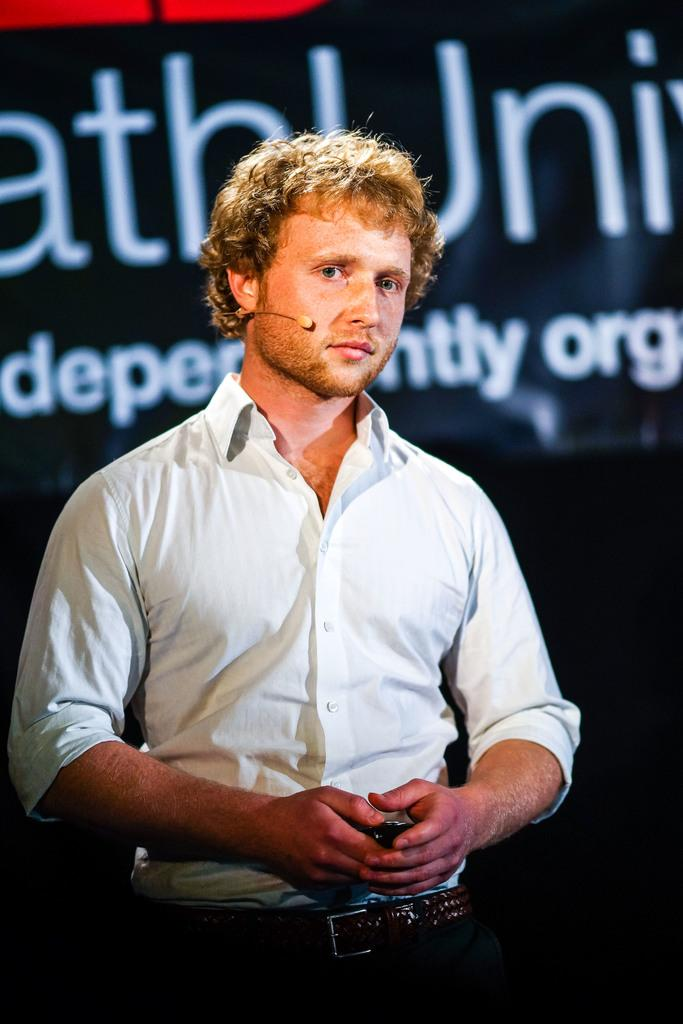Who is present in the image? There is a man in the image. What is the man wearing in the image? The man is wearing a microphone in the image. What can be seen in the background of the image? There is a banner in the background of the image. What type of pot is visible on the table in the image? There is no table or pot present in the image. How many spades are being used by the man in the image? The man is not using any spades in the image; he is wearing a microphone. 